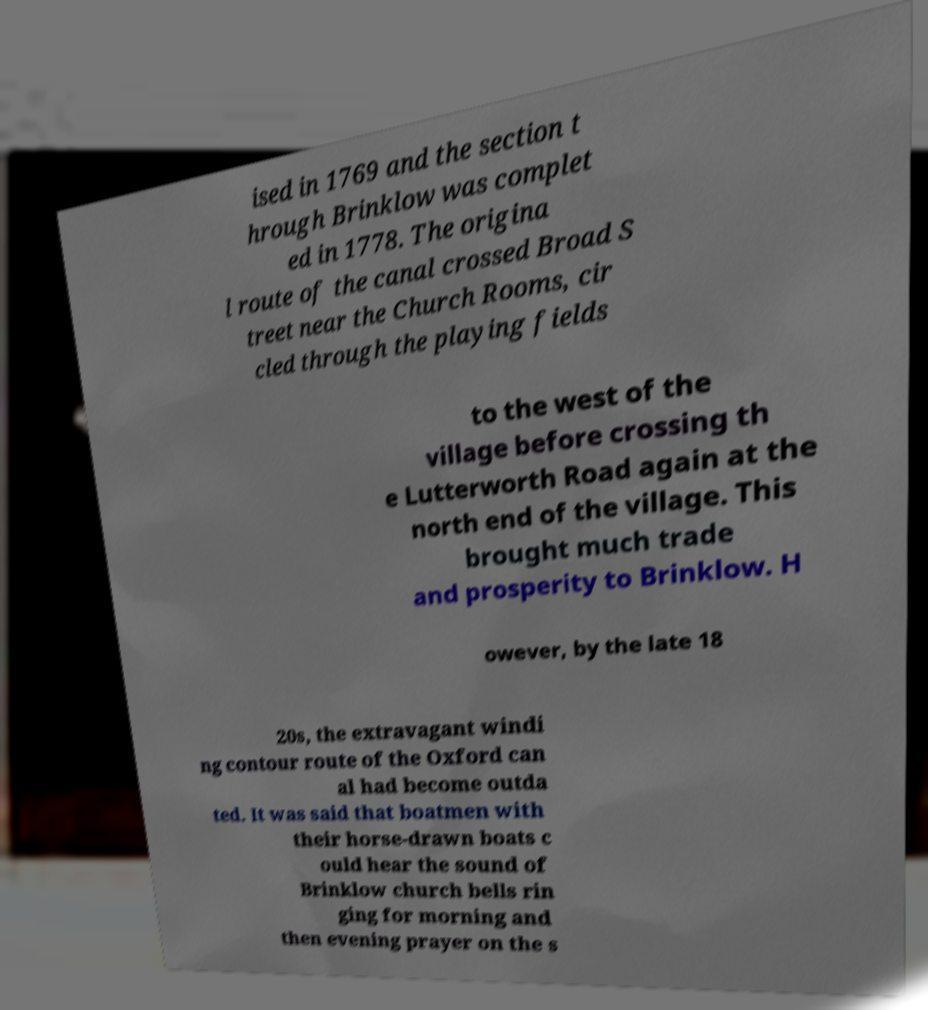Please read and relay the text visible in this image. What does it say? ised in 1769 and the section t hrough Brinklow was complet ed in 1778. The origina l route of the canal crossed Broad S treet near the Church Rooms, cir cled through the playing fields to the west of the village before crossing th e Lutterworth Road again at the north end of the village. This brought much trade and prosperity to Brinklow. H owever, by the late 18 20s, the extravagant windi ng contour route of the Oxford can al had become outda ted. It was said that boatmen with their horse-drawn boats c ould hear the sound of Brinklow church bells rin ging for morning and then evening prayer on the s 